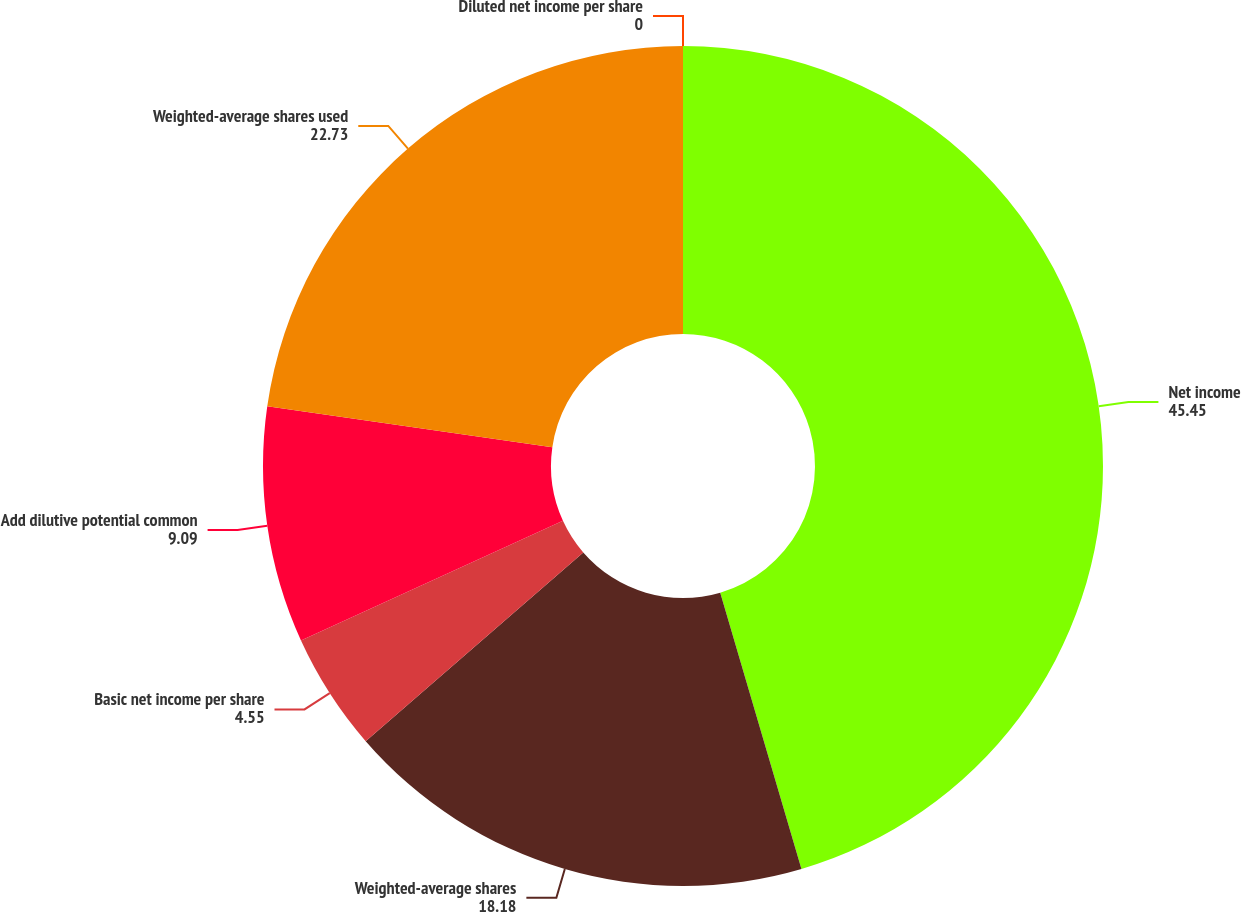<chart> <loc_0><loc_0><loc_500><loc_500><pie_chart><fcel>Net income<fcel>Weighted-average shares<fcel>Basic net income per share<fcel>Add dilutive potential common<fcel>Weighted-average shares used<fcel>Diluted net income per share<nl><fcel>45.45%<fcel>18.18%<fcel>4.55%<fcel>9.09%<fcel>22.73%<fcel>0.0%<nl></chart> 